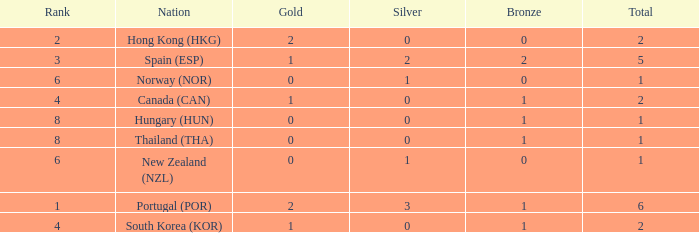Which Rank number has a Silver of 0, Gold of 2 and total smaller than 2? 0.0. 